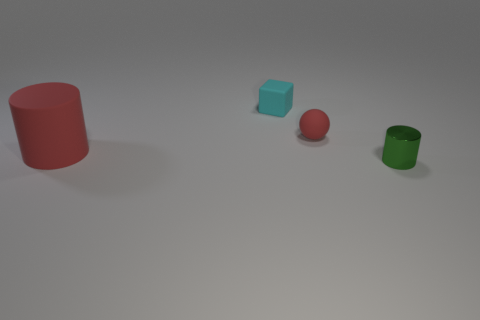Does the red matte thing that is in front of the red matte sphere have the same shape as the red object that is to the right of the matte block?
Make the answer very short. No. What is the size of the object that is the same color as the matte sphere?
Provide a succinct answer. Large. How many other things are the same size as the red matte cylinder?
Make the answer very short. 0. There is a small rubber sphere; is it the same color as the matte object that is on the left side of the cyan rubber object?
Your answer should be very brief. Yes. Is the number of red spheres that are behind the small red matte ball less than the number of tiny rubber spheres behind the big cylinder?
Provide a succinct answer. Yes. There is a matte thing that is both to the right of the big red cylinder and in front of the cyan thing; what is its color?
Offer a very short reply. Red. There is a green metal thing; does it have the same size as the cylinder that is behind the small cylinder?
Make the answer very short. No. The object left of the cyan block has what shape?
Offer a terse response. Cylinder. Is there any other thing that is the same material as the green cylinder?
Your answer should be very brief. No. Is the number of tiny red matte spheres behind the large rubber cylinder greater than the number of big gray shiny cylinders?
Your answer should be very brief. Yes. 